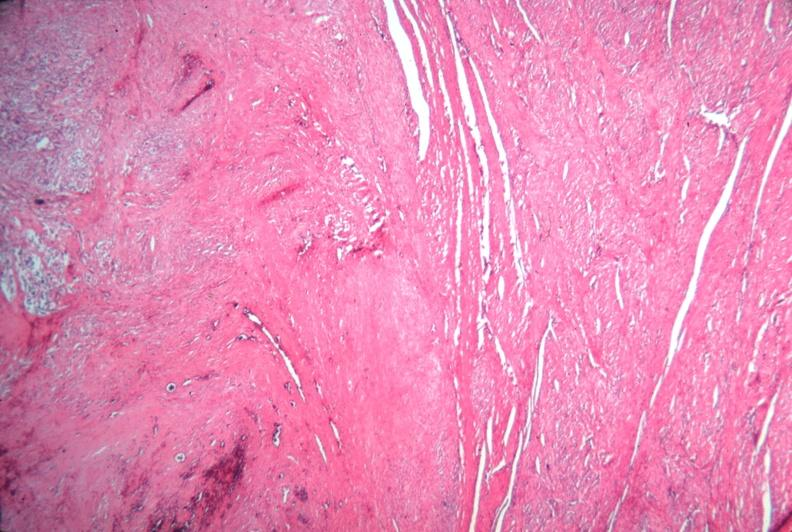what does this image show?
Answer the question using a single word or phrase. Uterus 